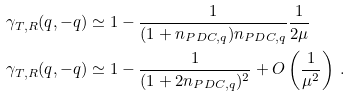Convert formula to latex. <formula><loc_0><loc_0><loc_500><loc_500>\gamma _ { T , R } ( q , - q ) & \simeq 1 - \frac { 1 } { ( 1 + n _ { P D C , q } ) n _ { P D C , q } } \frac { 1 } { 2 \mu } \\ \gamma _ { T , R } ( q , - q ) & \simeq 1 - \frac { 1 } { ( 1 + 2 n _ { P D C , q } ) ^ { 2 } } + O \left ( \frac { 1 } { \mu ^ { 2 } } \right ) \, .</formula> 